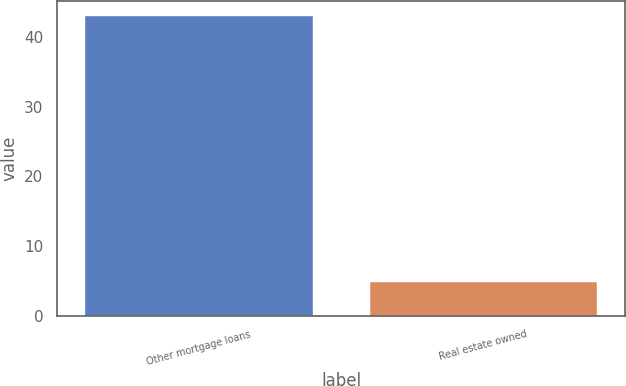<chart> <loc_0><loc_0><loc_500><loc_500><bar_chart><fcel>Other mortgage loans<fcel>Real estate owned<nl><fcel>43<fcel>4.9<nl></chart> 